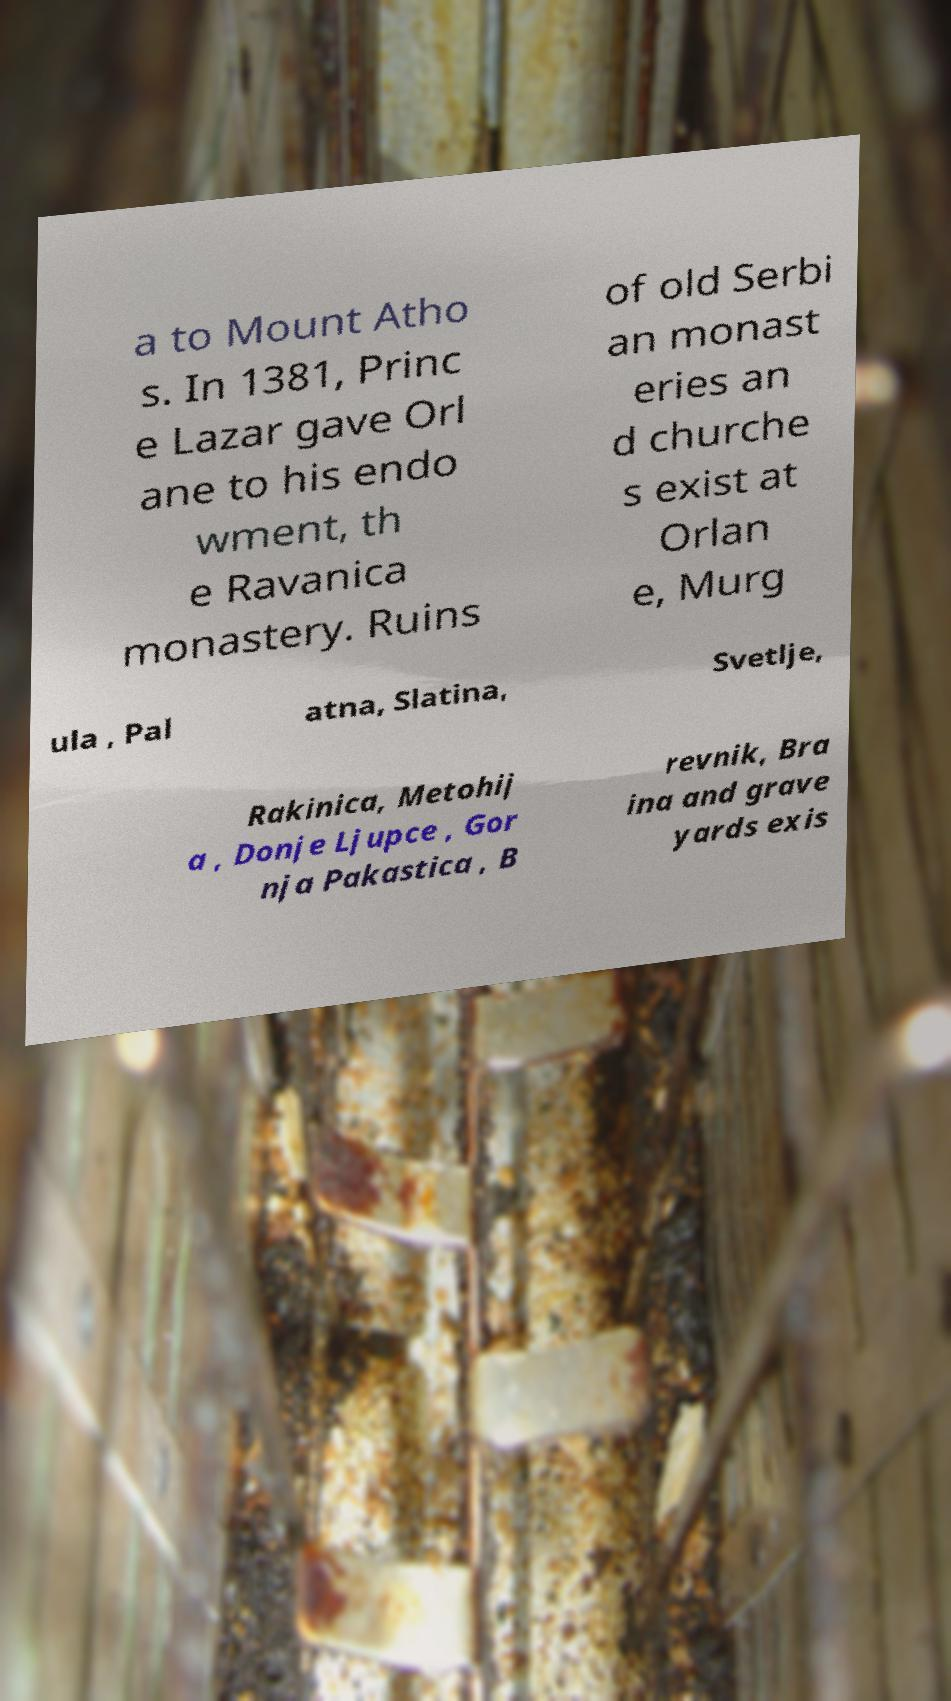Please identify and transcribe the text found in this image. a to Mount Atho s. In 1381, Princ e Lazar gave Orl ane to his endo wment, th e Ravanica monastery. Ruins of old Serbi an monast eries an d churche s exist at Orlan e, Murg ula , Pal atna, Slatina, Svetlje, Rakinica, Metohij a , Donje Ljupce , Gor nja Pakastica , B revnik, Bra ina and grave yards exis 